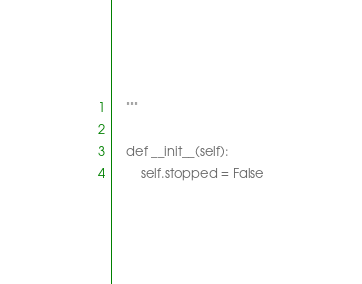<code> <loc_0><loc_0><loc_500><loc_500><_Python_>    """

    def __init__(self):
        self.stopped = False

</code> 